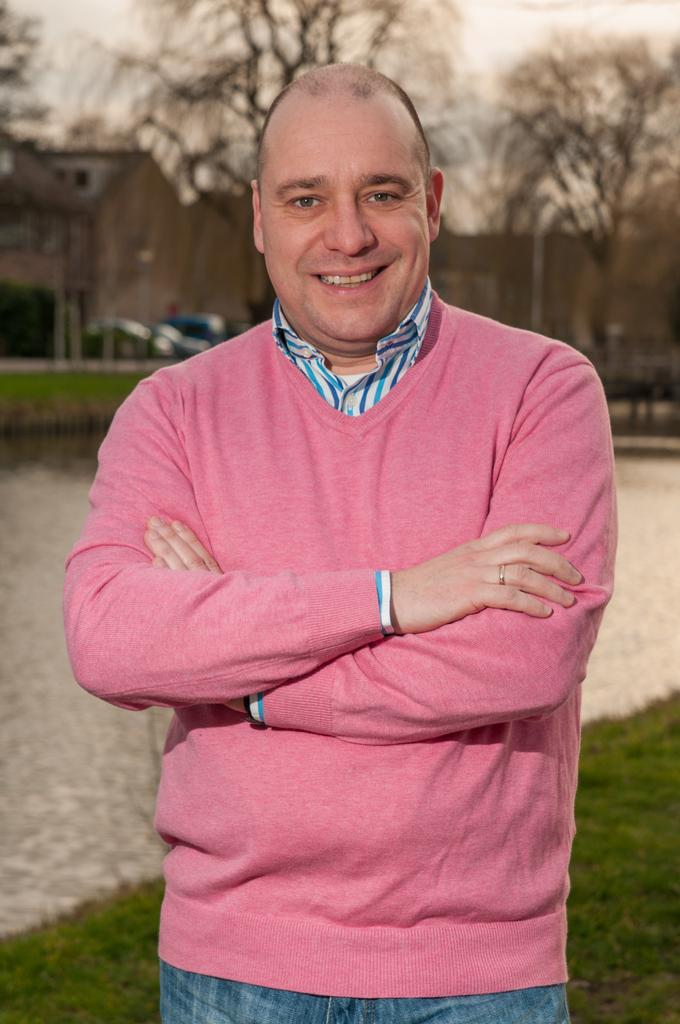What is the main subject in the foreground of the image? There is a person in the foreground of the image. What type of natural environment is visible behind the person? There is grass behind the person. What type of water body can be seen in the image? There is a water body in the image. What other elements can be seen in the background of the image? There are trees, vehicles, buildings, and the sky visible in the background of the image. What is the purpose of the crack in the water body in the image? There is no crack visible in the water body in the image. 